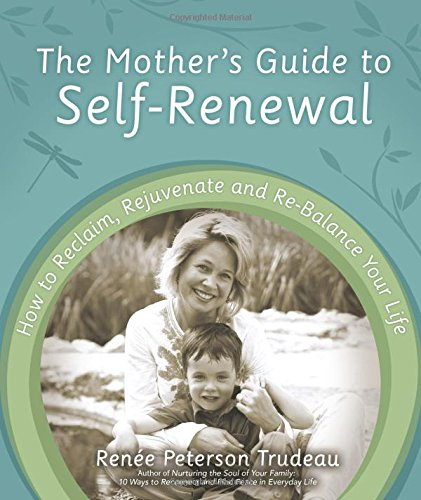Who wrote this book? The book 'The Mother's Guide to Self-Renewal' was authored by Renée Peterson Trudeau, who is well-known for her work on personal development and self-care for mothers. 